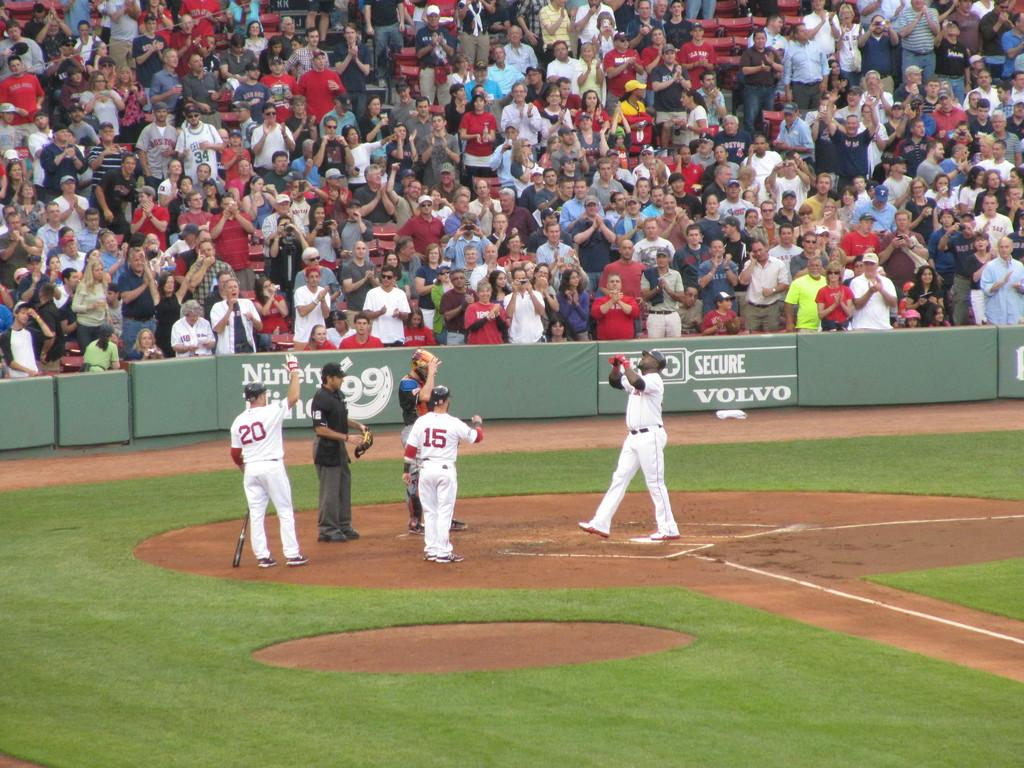Provide a one-sentence caption for the provided image. Players 20 and 15 greet their teammate at the plate. 